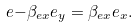<formula> <loc_0><loc_0><loc_500><loc_500>\ e { - \beta _ { e x } e _ { y } } = \beta _ { e x } e _ { x } .</formula> 